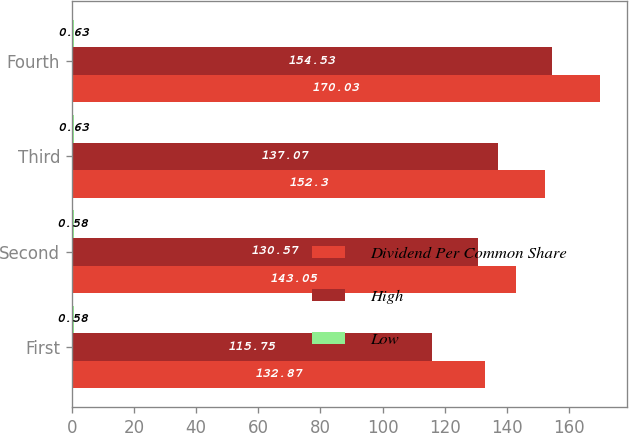Convert chart. <chart><loc_0><loc_0><loc_500><loc_500><stacked_bar_chart><ecel><fcel>First<fcel>Second<fcel>Third<fcel>Fourth<nl><fcel>Dividend Per Common Share<fcel>132.87<fcel>143.05<fcel>152.3<fcel>170.03<nl><fcel>High<fcel>115.75<fcel>130.57<fcel>137.07<fcel>154.53<nl><fcel>Low<fcel>0.58<fcel>0.58<fcel>0.63<fcel>0.63<nl></chart> 